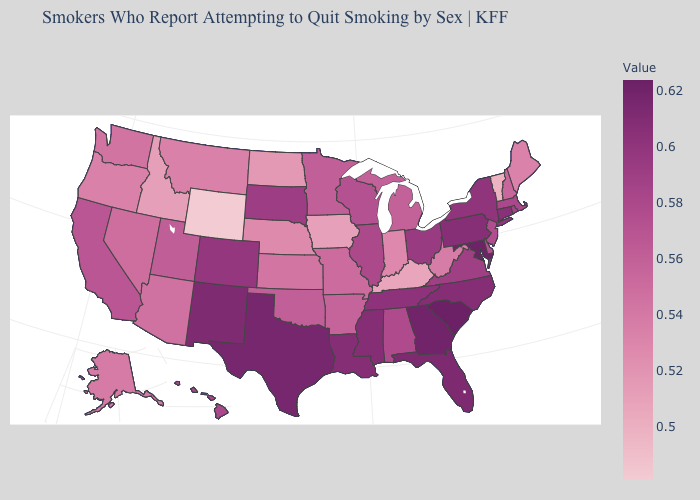Does Alaska have the lowest value in the West?
Give a very brief answer. No. Among the states that border California , does Oregon have the lowest value?
Answer briefly. Yes. Does the map have missing data?
Give a very brief answer. No. Which states hav the highest value in the South?
Write a very short answer. South Carolina. Does Maryland have the highest value in the USA?
Be succinct. No. Does Indiana have the highest value in the USA?
Quick response, please. No. Which states hav the highest value in the South?
Concise answer only. South Carolina. Does South Carolina have the highest value in the USA?
Quick response, please. Yes. Which states hav the highest value in the West?
Concise answer only. New Mexico. 